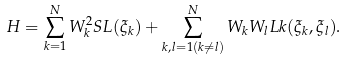Convert formula to latex. <formula><loc_0><loc_0><loc_500><loc_500>H = \sum _ { k = 1 } ^ { N } W _ { k } ^ { 2 } S L ( \xi _ { k } ) + \sum _ { k , l = 1 ( k \neq l ) } ^ { N } W _ { k } W _ { l } L k ( \xi _ { k } , \xi _ { l } ) .</formula> 